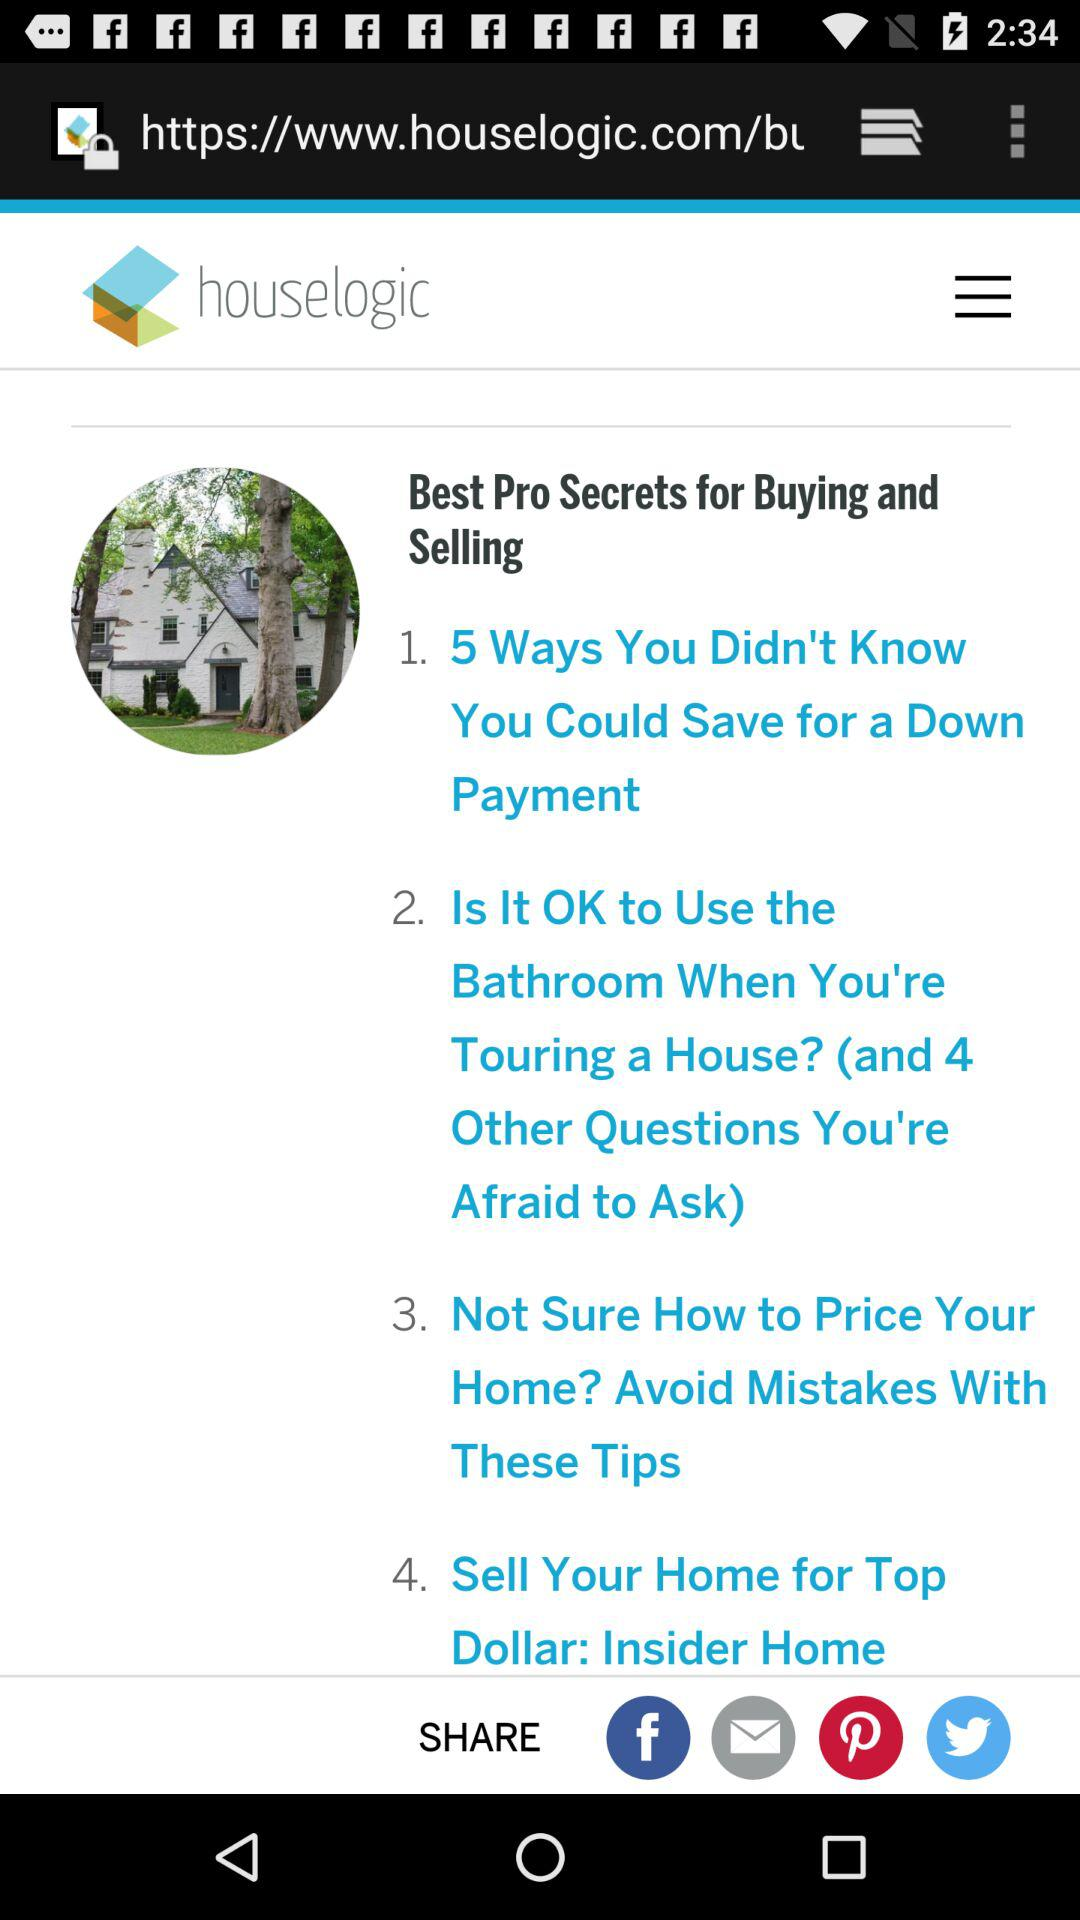How many more articles are there after the first one?
Answer the question using a single word or phrase. 3 